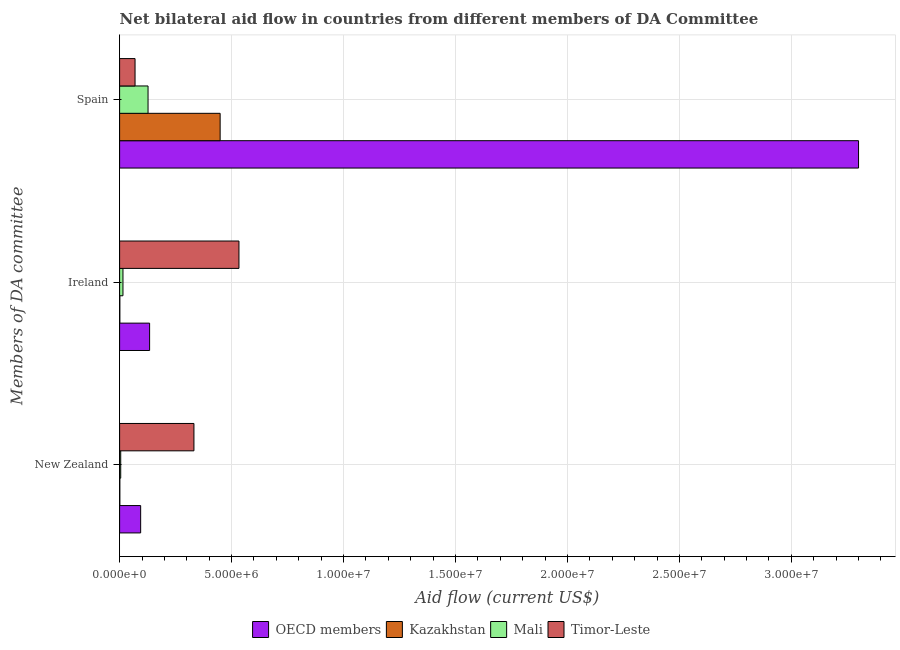How many groups of bars are there?
Ensure brevity in your answer.  3. Are the number of bars per tick equal to the number of legend labels?
Give a very brief answer. Yes. What is the label of the 2nd group of bars from the top?
Ensure brevity in your answer.  Ireland. What is the amount of aid provided by new zealand in Kazakhstan?
Offer a terse response. 10000. Across all countries, what is the maximum amount of aid provided by ireland?
Make the answer very short. 5.33e+06. Across all countries, what is the minimum amount of aid provided by new zealand?
Your response must be concise. 10000. In which country was the amount of aid provided by ireland maximum?
Offer a very short reply. Timor-Leste. In which country was the amount of aid provided by new zealand minimum?
Provide a succinct answer. Kazakhstan. What is the total amount of aid provided by spain in the graph?
Keep it short and to the point. 3.94e+07. What is the difference between the amount of aid provided by ireland in Timor-Leste and that in Kazakhstan?
Your response must be concise. 5.32e+06. What is the difference between the amount of aid provided by new zealand in Timor-Leste and the amount of aid provided by spain in Mali?
Your response must be concise. 2.05e+06. What is the average amount of aid provided by new zealand per country?
Your response must be concise. 1.08e+06. What is the difference between the amount of aid provided by new zealand and amount of aid provided by spain in Timor-Leste?
Ensure brevity in your answer.  2.63e+06. In how many countries, is the amount of aid provided by ireland greater than 24000000 US$?
Make the answer very short. 0. What is the ratio of the amount of aid provided by spain in OECD members to that in Mali?
Give a very brief answer. 25.98. Is the amount of aid provided by spain in Mali less than that in OECD members?
Provide a succinct answer. Yes. Is the difference between the amount of aid provided by spain in OECD members and Timor-Leste greater than the difference between the amount of aid provided by new zealand in OECD members and Timor-Leste?
Make the answer very short. Yes. What is the difference between the highest and the second highest amount of aid provided by ireland?
Your answer should be compact. 3.99e+06. What is the difference between the highest and the lowest amount of aid provided by new zealand?
Provide a short and direct response. 3.31e+06. In how many countries, is the amount of aid provided by new zealand greater than the average amount of aid provided by new zealand taken over all countries?
Offer a very short reply. 1. Is the sum of the amount of aid provided by spain in Mali and OECD members greater than the maximum amount of aid provided by new zealand across all countries?
Offer a very short reply. Yes. What does the 4th bar from the top in Spain represents?
Your response must be concise. OECD members. What does the 4th bar from the bottom in New Zealand represents?
Your answer should be compact. Timor-Leste. Is it the case that in every country, the sum of the amount of aid provided by new zealand and amount of aid provided by ireland is greater than the amount of aid provided by spain?
Make the answer very short. No. Where does the legend appear in the graph?
Offer a very short reply. Bottom center. What is the title of the graph?
Offer a terse response. Net bilateral aid flow in countries from different members of DA Committee. What is the label or title of the Y-axis?
Provide a succinct answer. Members of DA committee. What is the Aid flow (current US$) of OECD members in New Zealand?
Provide a short and direct response. 9.40e+05. What is the Aid flow (current US$) of Kazakhstan in New Zealand?
Your answer should be very brief. 10000. What is the Aid flow (current US$) in Mali in New Zealand?
Give a very brief answer. 5.00e+04. What is the Aid flow (current US$) of Timor-Leste in New Zealand?
Your answer should be very brief. 3.32e+06. What is the Aid flow (current US$) in OECD members in Ireland?
Keep it short and to the point. 1.34e+06. What is the Aid flow (current US$) in Kazakhstan in Ireland?
Give a very brief answer. 10000. What is the Aid flow (current US$) of Mali in Ireland?
Your answer should be very brief. 1.50e+05. What is the Aid flow (current US$) in Timor-Leste in Ireland?
Provide a short and direct response. 5.33e+06. What is the Aid flow (current US$) in OECD members in Spain?
Provide a short and direct response. 3.30e+07. What is the Aid flow (current US$) in Kazakhstan in Spain?
Offer a terse response. 4.49e+06. What is the Aid flow (current US$) of Mali in Spain?
Provide a short and direct response. 1.27e+06. What is the Aid flow (current US$) of Timor-Leste in Spain?
Ensure brevity in your answer.  6.90e+05. Across all Members of DA committee, what is the maximum Aid flow (current US$) of OECD members?
Give a very brief answer. 3.30e+07. Across all Members of DA committee, what is the maximum Aid flow (current US$) of Kazakhstan?
Provide a short and direct response. 4.49e+06. Across all Members of DA committee, what is the maximum Aid flow (current US$) in Mali?
Offer a very short reply. 1.27e+06. Across all Members of DA committee, what is the maximum Aid flow (current US$) in Timor-Leste?
Give a very brief answer. 5.33e+06. Across all Members of DA committee, what is the minimum Aid flow (current US$) of OECD members?
Ensure brevity in your answer.  9.40e+05. Across all Members of DA committee, what is the minimum Aid flow (current US$) in Mali?
Keep it short and to the point. 5.00e+04. Across all Members of DA committee, what is the minimum Aid flow (current US$) in Timor-Leste?
Offer a terse response. 6.90e+05. What is the total Aid flow (current US$) of OECD members in the graph?
Your response must be concise. 3.53e+07. What is the total Aid flow (current US$) in Kazakhstan in the graph?
Provide a succinct answer. 4.51e+06. What is the total Aid flow (current US$) in Mali in the graph?
Keep it short and to the point. 1.47e+06. What is the total Aid flow (current US$) in Timor-Leste in the graph?
Provide a succinct answer. 9.34e+06. What is the difference between the Aid flow (current US$) of OECD members in New Zealand and that in Ireland?
Offer a terse response. -4.00e+05. What is the difference between the Aid flow (current US$) in Mali in New Zealand and that in Ireland?
Offer a very short reply. -1.00e+05. What is the difference between the Aid flow (current US$) in Timor-Leste in New Zealand and that in Ireland?
Make the answer very short. -2.01e+06. What is the difference between the Aid flow (current US$) of OECD members in New Zealand and that in Spain?
Give a very brief answer. -3.21e+07. What is the difference between the Aid flow (current US$) in Kazakhstan in New Zealand and that in Spain?
Provide a succinct answer. -4.48e+06. What is the difference between the Aid flow (current US$) of Mali in New Zealand and that in Spain?
Your answer should be very brief. -1.22e+06. What is the difference between the Aid flow (current US$) in Timor-Leste in New Zealand and that in Spain?
Keep it short and to the point. 2.63e+06. What is the difference between the Aid flow (current US$) of OECD members in Ireland and that in Spain?
Provide a succinct answer. -3.17e+07. What is the difference between the Aid flow (current US$) of Kazakhstan in Ireland and that in Spain?
Your answer should be compact. -4.48e+06. What is the difference between the Aid flow (current US$) of Mali in Ireland and that in Spain?
Your response must be concise. -1.12e+06. What is the difference between the Aid flow (current US$) in Timor-Leste in Ireland and that in Spain?
Make the answer very short. 4.64e+06. What is the difference between the Aid flow (current US$) in OECD members in New Zealand and the Aid flow (current US$) in Kazakhstan in Ireland?
Your response must be concise. 9.30e+05. What is the difference between the Aid flow (current US$) in OECD members in New Zealand and the Aid flow (current US$) in Mali in Ireland?
Provide a succinct answer. 7.90e+05. What is the difference between the Aid flow (current US$) in OECD members in New Zealand and the Aid flow (current US$) in Timor-Leste in Ireland?
Your answer should be very brief. -4.39e+06. What is the difference between the Aid flow (current US$) of Kazakhstan in New Zealand and the Aid flow (current US$) of Timor-Leste in Ireland?
Your answer should be very brief. -5.32e+06. What is the difference between the Aid flow (current US$) in Mali in New Zealand and the Aid flow (current US$) in Timor-Leste in Ireland?
Ensure brevity in your answer.  -5.28e+06. What is the difference between the Aid flow (current US$) of OECD members in New Zealand and the Aid flow (current US$) of Kazakhstan in Spain?
Your answer should be compact. -3.55e+06. What is the difference between the Aid flow (current US$) of OECD members in New Zealand and the Aid flow (current US$) of Mali in Spain?
Your response must be concise. -3.30e+05. What is the difference between the Aid flow (current US$) in OECD members in New Zealand and the Aid flow (current US$) in Timor-Leste in Spain?
Your answer should be compact. 2.50e+05. What is the difference between the Aid flow (current US$) of Kazakhstan in New Zealand and the Aid flow (current US$) of Mali in Spain?
Provide a succinct answer. -1.26e+06. What is the difference between the Aid flow (current US$) of Kazakhstan in New Zealand and the Aid flow (current US$) of Timor-Leste in Spain?
Your answer should be compact. -6.80e+05. What is the difference between the Aid flow (current US$) in Mali in New Zealand and the Aid flow (current US$) in Timor-Leste in Spain?
Your response must be concise. -6.40e+05. What is the difference between the Aid flow (current US$) in OECD members in Ireland and the Aid flow (current US$) in Kazakhstan in Spain?
Provide a succinct answer. -3.15e+06. What is the difference between the Aid flow (current US$) in OECD members in Ireland and the Aid flow (current US$) in Timor-Leste in Spain?
Your answer should be compact. 6.50e+05. What is the difference between the Aid flow (current US$) in Kazakhstan in Ireland and the Aid flow (current US$) in Mali in Spain?
Give a very brief answer. -1.26e+06. What is the difference between the Aid flow (current US$) in Kazakhstan in Ireland and the Aid flow (current US$) in Timor-Leste in Spain?
Give a very brief answer. -6.80e+05. What is the difference between the Aid flow (current US$) in Mali in Ireland and the Aid flow (current US$) in Timor-Leste in Spain?
Provide a succinct answer. -5.40e+05. What is the average Aid flow (current US$) of OECD members per Members of DA committee?
Make the answer very short. 1.18e+07. What is the average Aid flow (current US$) in Kazakhstan per Members of DA committee?
Your answer should be compact. 1.50e+06. What is the average Aid flow (current US$) in Mali per Members of DA committee?
Provide a short and direct response. 4.90e+05. What is the average Aid flow (current US$) of Timor-Leste per Members of DA committee?
Your answer should be compact. 3.11e+06. What is the difference between the Aid flow (current US$) of OECD members and Aid flow (current US$) of Kazakhstan in New Zealand?
Your answer should be very brief. 9.30e+05. What is the difference between the Aid flow (current US$) in OECD members and Aid flow (current US$) in Mali in New Zealand?
Provide a succinct answer. 8.90e+05. What is the difference between the Aid flow (current US$) of OECD members and Aid flow (current US$) of Timor-Leste in New Zealand?
Ensure brevity in your answer.  -2.38e+06. What is the difference between the Aid flow (current US$) of Kazakhstan and Aid flow (current US$) of Mali in New Zealand?
Ensure brevity in your answer.  -4.00e+04. What is the difference between the Aid flow (current US$) in Kazakhstan and Aid flow (current US$) in Timor-Leste in New Zealand?
Your answer should be very brief. -3.31e+06. What is the difference between the Aid flow (current US$) in Mali and Aid flow (current US$) in Timor-Leste in New Zealand?
Your response must be concise. -3.27e+06. What is the difference between the Aid flow (current US$) in OECD members and Aid flow (current US$) in Kazakhstan in Ireland?
Your response must be concise. 1.33e+06. What is the difference between the Aid flow (current US$) in OECD members and Aid flow (current US$) in Mali in Ireland?
Your answer should be very brief. 1.19e+06. What is the difference between the Aid flow (current US$) in OECD members and Aid flow (current US$) in Timor-Leste in Ireland?
Provide a succinct answer. -3.99e+06. What is the difference between the Aid flow (current US$) in Kazakhstan and Aid flow (current US$) in Timor-Leste in Ireland?
Offer a very short reply. -5.32e+06. What is the difference between the Aid flow (current US$) of Mali and Aid flow (current US$) of Timor-Leste in Ireland?
Provide a succinct answer. -5.18e+06. What is the difference between the Aid flow (current US$) in OECD members and Aid flow (current US$) in Kazakhstan in Spain?
Your answer should be very brief. 2.85e+07. What is the difference between the Aid flow (current US$) of OECD members and Aid flow (current US$) of Mali in Spain?
Provide a succinct answer. 3.17e+07. What is the difference between the Aid flow (current US$) of OECD members and Aid flow (current US$) of Timor-Leste in Spain?
Your answer should be very brief. 3.23e+07. What is the difference between the Aid flow (current US$) in Kazakhstan and Aid flow (current US$) in Mali in Spain?
Your answer should be compact. 3.22e+06. What is the difference between the Aid flow (current US$) in Kazakhstan and Aid flow (current US$) in Timor-Leste in Spain?
Make the answer very short. 3.80e+06. What is the difference between the Aid flow (current US$) in Mali and Aid flow (current US$) in Timor-Leste in Spain?
Offer a terse response. 5.80e+05. What is the ratio of the Aid flow (current US$) of OECD members in New Zealand to that in Ireland?
Give a very brief answer. 0.7. What is the ratio of the Aid flow (current US$) of Kazakhstan in New Zealand to that in Ireland?
Make the answer very short. 1. What is the ratio of the Aid flow (current US$) of Timor-Leste in New Zealand to that in Ireland?
Provide a short and direct response. 0.62. What is the ratio of the Aid flow (current US$) of OECD members in New Zealand to that in Spain?
Your answer should be very brief. 0.03. What is the ratio of the Aid flow (current US$) of Kazakhstan in New Zealand to that in Spain?
Keep it short and to the point. 0. What is the ratio of the Aid flow (current US$) in Mali in New Zealand to that in Spain?
Provide a succinct answer. 0.04. What is the ratio of the Aid flow (current US$) in Timor-Leste in New Zealand to that in Spain?
Offer a very short reply. 4.81. What is the ratio of the Aid flow (current US$) in OECD members in Ireland to that in Spain?
Keep it short and to the point. 0.04. What is the ratio of the Aid flow (current US$) of Kazakhstan in Ireland to that in Spain?
Your answer should be compact. 0. What is the ratio of the Aid flow (current US$) in Mali in Ireland to that in Spain?
Ensure brevity in your answer.  0.12. What is the ratio of the Aid flow (current US$) in Timor-Leste in Ireland to that in Spain?
Your answer should be very brief. 7.72. What is the difference between the highest and the second highest Aid flow (current US$) of OECD members?
Keep it short and to the point. 3.17e+07. What is the difference between the highest and the second highest Aid flow (current US$) of Kazakhstan?
Give a very brief answer. 4.48e+06. What is the difference between the highest and the second highest Aid flow (current US$) of Mali?
Provide a short and direct response. 1.12e+06. What is the difference between the highest and the second highest Aid flow (current US$) of Timor-Leste?
Your answer should be compact. 2.01e+06. What is the difference between the highest and the lowest Aid flow (current US$) in OECD members?
Offer a very short reply. 3.21e+07. What is the difference between the highest and the lowest Aid flow (current US$) of Kazakhstan?
Offer a terse response. 4.48e+06. What is the difference between the highest and the lowest Aid flow (current US$) in Mali?
Offer a terse response. 1.22e+06. What is the difference between the highest and the lowest Aid flow (current US$) in Timor-Leste?
Provide a succinct answer. 4.64e+06. 